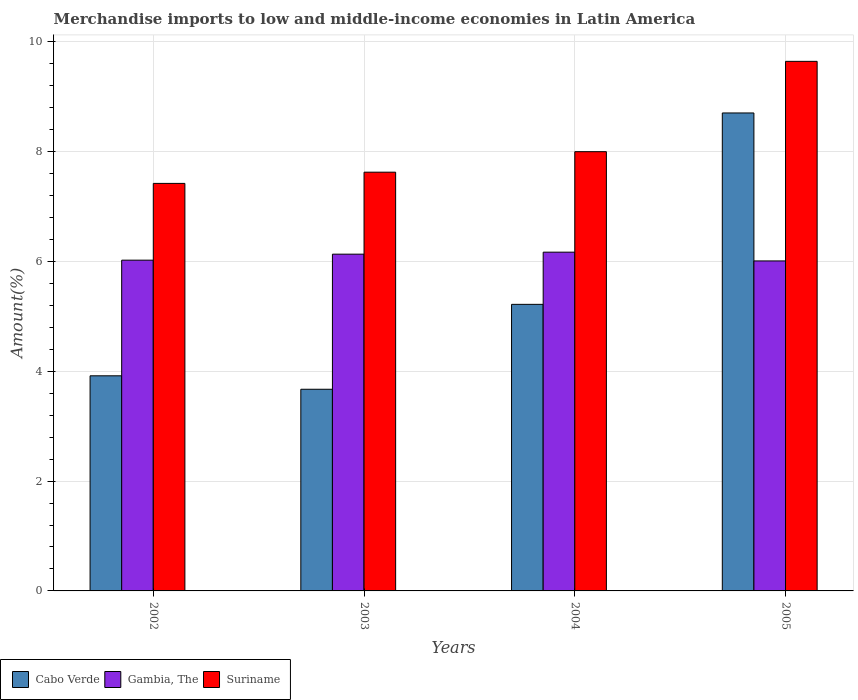How many different coloured bars are there?
Your response must be concise. 3. Are the number of bars on each tick of the X-axis equal?
Your response must be concise. Yes. What is the label of the 2nd group of bars from the left?
Your response must be concise. 2003. In how many cases, is the number of bars for a given year not equal to the number of legend labels?
Provide a short and direct response. 0. What is the percentage of amount earned from merchandise imports in Gambia, The in 2004?
Provide a short and direct response. 6.17. Across all years, what is the maximum percentage of amount earned from merchandise imports in Gambia, The?
Ensure brevity in your answer.  6.17. Across all years, what is the minimum percentage of amount earned from merchandise imports in Gambia, The?
Ensure brevity in your answer.  6.01. In which year was the percentage of amount earned from merchandise imports in Gambia, The minimum?
Offer a terse response. 2005. What is the total percentage of amount earned from merchandise imports in Suriname in the graph?
Provide a succinct answer. 32.68. What is the difference between the percentage of amount earned from merchandise imports in Gambia, The in 2003 and that in 2004?
Your response must be concise. -0.04. What is the difference between the percentage of amount earned from merchandise imports in Gambia, The in 2003 and the percentage of amount earned from merchandise imports in Suriname in 2004?
Your response must be concise. -1.87. What is the average percentage of amount earned from merchandise imports in Gambia, The per year?
Your response must be concise. 6.08. In the year 2002, what is the difference between the percentage of amount earned from merchandise imports in Suriname and percentage of amount earned from merchandise imports in Cabo Verde?
Offer a very short reply. 3.5. In how many years, is the percentage of amount earned from merchandise imports in Suriname greater than 6 %?
Your answer should be very brief. 4. What is the ratio of the percentage of amount earned from merchandise imports in Cabo Verde in 2002 to that in 2005?
Keep it short and to the point. 0.45. Is the percentage of amount earned from merchandise imports in Gambia, The in 2004 less than that in 2005?
Offer a terse response. No. Is the difference between the percentage of amount earned from merchandise imports in Suriname in 2002 and 2003 greater than the difference between the percentage of amount earned from merchandise imports in Cabo Verde in 2002 and 2003?
Ensure brevity in your answer.  No. What is the difference between the highest and the second highest percentage of amount earned from merchandise imports in Suriname?
Your answer should be very brief. 1.64. What is the difference between the highest and the lowest percentage of amount earned from merchandise imports in Gambia, The?
Keep it short and to the point. 0.16. In how many years, is the percentage of amount earned from merchandise imports in Gambia, The greater than the average percentage of amount earned from merchandise imports in Gambia, The taken over all years?
Make the answer very short. 2. Is the sum of the percentage of amount earned from merchandise imports in Suriname in 2002 and 2003 greater than the maximum percentage of amount earned from merchandise imports in Gambia, The across all years?
Keep it short and to the point. Yes. What does the 1st bar from the left in 2002 represents?
Give a very brief answer. Cabo Verde. What does the 2nd bar from the right in 2005 represents?
Offer a very short reply. Gambia, The. How many years are there in the graph?
Your answer should be compact. 4. Are the values on the major ticks of Y-axis written in scientific E-notation?
Offer a terse response. No. Does the graph contain grids?
Your response must be concise. Yes. Where does the legend appear in the graph?
Ensure brevity in your answer.  Bottom left. How are the legend labels stacked?
Offer a very short reply. Horizontal. What is the title of the graph?
Give a very brief answer. Merchandise imports to low and middle-income economies in Latin America. What is the label or title of the Y-axis?
Your response must be concise. Amount(%). What is the Amount(%) in Cabo Verde in 2002?
Offer a terse response. 3.92. What is the Amount(%) of Gambia, The in 2002?
Your answer should be compact. 6.02. What is the Amount(%) in Suriname in 2002?
Ensure brevity in your answer.  7.42. What is the Amount(%) in Cabo Verde in 2003?
Make the answer very short. 3.67. What is the Amount(%) in Gambia, The in 2003?
Offer a very short reply. 6.13. What is the Amount(%) in Suriname in 2003?
Provide a succinct answer. 7.62. What is the Amount(%) in Cabo Verde in 2004?
Ensure brevity in your answer.  5.22. What is the Amount(%) of Gambia, The in 2004?
Your response must be concise. 6.17. What is the Amount(%) of Suriname in 2004?
Give a very brief answer. 8. What is the Amount(%) of Cabo Verde in 2005?
Your answer should be compact. 8.7. What is the Amount(%) of Gambia, The in 2005?
Provide a short and direct response. 6.01. What is the Amount(%) in Suriname in 2005?
Your response must be concise. 9.64. Across all years, what is the maximum Amount(%) in Cabo Verde?
Keep it short and to the point. 8.7. Across all years, what is the maximum Amount(%) in Gambia, The?
Your answer should be compact. 6.17. Across all years, what is the maximum Amount(%) in Suriname?
Your response must be concise. 9.64. Across all years, what is the minimum Amount(%) in Cabo Verde?
Keep it short and to the point. 3.67. Across all years, what is the minimum Amount(%) in Gambia, The?
Your response must be concise. 6.01. Across all years, what is the minimum Amount(%) of Suriname?
Provide a short and direct response. 7.42. What is the total Amount(%) in Cabo Verde in the graph?
Offer a very short reply. 21.51. What is the total Amount(%) in Gambia, The in the graph?
Give a very brief answer. 24.33. What is the total Amount(%) in Suriname in the graph?
Keep it short and to the point. 32.68. What is the difference between the Amount(%) in Cabo Verde in 2002 and that in 2003?
Provide a short and direct response. 0.24. What is the difference between the Amount(%) of Gambia, The in 2002 and that in 2003?
Your response must be concise. -0.11. What is the difference between the Amount(%) of Suriname in 2002 and that in 2003?
Your answer should be very brief. -0.2. What is the difference between the Amount(%) in Cabo Verde in 2002 and that in 2004?
Your answer should be compact. -1.3. What is the difference between the Amount(%) in Gambia, The in 2002 and that in 2004?
Your answer should be very brief. -0.15. What is the difference between the Amount(%) in Suriname in 2002 and that in 2004?
Your answer should be very brief. -0.58. What is the difference between the Amount(%) in Cabo Verde in 2002 and that in 2005?
Your response must be concise. -4.79. What is the difference between the Amount(%) in Gambia, The in 2002 and that in 2005?
Your answer should be very brief. 0.01. What is the difference between the Amount(%) in Suriname in 2002 and that in 2005?
Your response must be concise. -2.22. What is the difference between the Amount(%) of Cabo Verde in 2003 and that in 2004?
Your answer should be very brief. -1.55. What is the difference between the Amount(%) of Gambia, The in 2003 and that in 2004?
Provide a short and direct response. -0.04. What is the difference between the Amount(%) of Suriname in 2003 and that in 2004?
Provide a succinct answer. -0.37. What is the difference between the Amount(%) of Cabo Verde in 2003 and that in 2005?
Ensure brevity in your answer.  -5.03. What is the difference between the Amount(%) in Gambia, The in 2003 and that in 2005?
Give a very brief answer. 0.12. What is the difference between the Amount(%) in Suriname in 2003 and that in 2005?
Your answer should be compact. -2.02. What is the difference between the Amount(%) of Cabo Verde in 2004 and that in 2005?
Make the answer very short. -3.48. What is the difference between the Amount(%) in Gambia, The in 2004 and that in 2005?
Your answer should be compact. 0.16. What is the difference between the Amount(%) of Suriname in 2004 and that in 2005?
Offer a terse response. -1.64. What is the difference between the Amount(%) of Cabo Verde in 2002 and the Amount(%) of Gambia, The in 2003?
Ensure brevity in your answer.  -2.21. What is the difference between the Amount(%) of Cabo Verde in 2002 and the Amount(%) of Suriname in 2003?
Provide a short and direct response. -3.71. What is the difference between the Amount(%) of Gambia, The in 2002 and the Amount(%) of Suriname in 2003?
Make the answer very short. -1.6. What is the difference between the Amount(%) of Cabo Verde in 2002 and the Amount(%) of Gambia, The in 2004?
Your answer should be compact. -2.25. What is the difference between the Amount(%) in Cabo Verde in 2002 and the Amount(%) in Suriname in 2004?
Offer a very short reply. -4.08. What is the difference between the Amount(%) in Gambia, The in 2002 and the Amount(%) in Suriname in 2004?
Give a very brief answer. -1.97. What is the difference between the Amount(%) in Cabo Verde in 2002 and the Amount(%) in Gambia, The in 2005?
Give a very brief answer. -2.09. What is the difference between the Amount(%) of Cabo Verde in 2002 and the Amount(%) of Suriname in 2005?
Ensure brevity in your answer.  -5.72. What is the difference between the Amount(%) of Gambia, The in 2002 and the Amount(%) of Suriname in 2005?
Provide a succinct answer. -3.62. What is the difference between the Amount(%) of Cabo Verde in 2003 and the Amount(%) of Gambia, The in 2004?
Offer a very short reply. -2.5. What is the difference between the Amount(%) in Cabo Verde in 2003 and the Amount(%) in Suriname in 2004?
Give a very brief answer. -4.33. What is the difference between the Amount(%) of Gambia, The in 2003 and the Amount(%) of Suriname in 2004?
Ensure brevity in your answer.  -1.87. What is the difference between the Amount(%) in Cabo Verde in 2003 and the Amount(%) in Gambia, The in 2005?
Provide a short and direct response. -2.34. What is the difference between the Amount(%) in Cabo Verde in 2003 and the Amount(%) in Suriname in 2005?
Make the answer very short. -5.97. What is the difference between the Amount(%) of Gambia, The in 2003 and the Amount(%) of Suriname in 2005?
Keep it short and to the point. -3.51. What is the difference between the Amount(%) of Cabo Verde in 2004 and the Amount(%) of Gambia, The in 2005?
Provide a succinct answer. -0.79. What is the difference between the Amount(%) in Cabo Verde in 2004 and the Amount(%) in Suriname in 2005?
Ensure brevity in your answer.  -4.42. What is the difference between the Amount(%) in Gambia, The in 2004 and the Amount(%) in Suriname in 2005?
Provide a succinct answer. -3.47. What is the average Amount(%) in Cabo Verde per year?
Make the answer very short. 5.38. What is the average Amount(%) of Gambia, The per year?
Provide a short and direct response. 6.08. What is the average Amount(%) in Suriname per year?
Your response must be concise. 8.17. In the year 2002, what is the difference between the Amount(%) of Cabo Verde and Amount(%) of Gambia, The?
Your answer should be compact. -2.11. In the year 2002, what is the difference between the Amount(%) in Cabo Verde and Amount(%) in Suriname?
Keep it short and to the point. -3.5. In the year 2002, what is the difference between the Amount(%) in Gambia, The and Amount(%) in Suriname?
Your answer should be very brief. -1.4. In the year 2003, what is the difference between the Amount(%) in Cabo Verde and Amount(%) in Gambia, The?
Keep it short and to the point. -2.46. In the year 2003, what is the difference between the Amount(%) in Cabo Verde and Amount(%) in Suriname?
Your answer should be very brief. -3.95. In the year 2003, what is the difference between the Amount(%) of Gambia, The and Amount(%) of Suriname?
Offer a very short reply. -1.49. In the year 2004, what is the difference between the Amount(%) in Cabo Verde and Amount(%) in Gambia, The?
Your answer should be very brief. -0.95. In the year 2004, what is the difference between the Amount(%) in Cabo Verde and Amount(%) in Suriname?
Give a very brief answer. -2.78. In the year 2004, what is the difference between the Amount(%) of Gambia, The and Amount(%) of Suriname?
Make the answer very short. -1.83. In the year 2005, what is the difference between the Amount(%) of Cabo Verde and Amount(%) of Gambia, The?
Your answer should be compact. 2.69. In the year 2005, what is the difference between the Amount(%) in Cabo Verde and Amount(%) in Suriname?
Your response must be concise. -0.94. In the year 2005, what is the difference between the Amount(%) of Gambia, The and Amount(%) of Suriname?
Give a very brief answer. -3.63. What is the ratio of the Amount(%) in Cabo Verde in 2002 to that in 2003?
Offer a very short reply. 1.07. What is the ratio of the Amount(%) in Gambia, The in 2002 to that in 2003?
Your response must be concise. 0.98. What is the ratio of the Amount(%) of Suriname in 2002 to that in 2003?
Provide a succinct answer. 0.97. What is the ratio of the Amount(%) of Cabo Verde in 2002 to that in 2004?
Provide a succinct answer. 0.75. What is the ratio of the Amount(%) in Gambia, The in 2002 to that in 2004?
Ensure brevity in your answer.  0.98. What is the ratio of the Amount(%) in Suriname in 2002 to that in 2004?
Your answer should be compact. 0.93. What is the ratio of the Amount(%) of Cabo Verde in 2002 to that in 2005?
Your response must be concise. 0.45. What is the ratio of the Amount(%) in Gambia, The in 2002 to that in 2005?
Make the answer very short. 1. What is the ratio of the Amount(%) of Suriname in 2002 to that in 2005?
Offer a terse response. 0.77. What is the ratio of the Amount(%) in Cabo Verde in 2003 to that in 2004?
Provide a succinct answer. 0.7. What is the ratio of the Amount(%) of Suriname in 2003 to that in 2004?
Ensure brevity in your answer.  0.95. What is the ratio of the Amount(%) in Cabo Verde in 2003 to that in 2005?
Your answer should be compact. 0.42. What is the ratio of the Amount(%) in Gambia, The in 2003 to that in 2005?
Ensure brevity in your answer.  1.02. What is the ratio of the Amount(%) of Suriname in 2003 to that in 2005?
Ensure brevity in your answer.  0.79. What is the ratio of the Amount(%) of Cabo Verde in 2004 to that in 2005?
Your answer should be very brief. 0.6. What is the ratio of the Amount(%) of Gambia, The in 2004 to that in 2005?
Your response must be concise. 1.03. What is the ratio of the Amount(%) in Suriname in 2004 to that in 2005?
Provide a succinct answer. 0.83. What is the difference between the highest and the second highest Amount(%) of Cabo Verde?
Provide a succinct answer. 3.48. What is the difference between the highest and the second highest Amount(%) in Gambia, The?
Ensure brevity in your answer.  0.04. What is the difference between the highest and the second highest Amount(%) in Suriname?
Make the answer very short. 1.64. What is the difference between the highest and the lowest Amount(%) of Cabo Verde?
Your answer should be compact. 5.03. What is the difference between the highest and the lowest Amount(%) in Gambia, The?
Provide a short and direct response. 0.16. What is the difference between the highest and the lowest Amount(%) in Suriname?
Give a very brief answer. 2.22. 